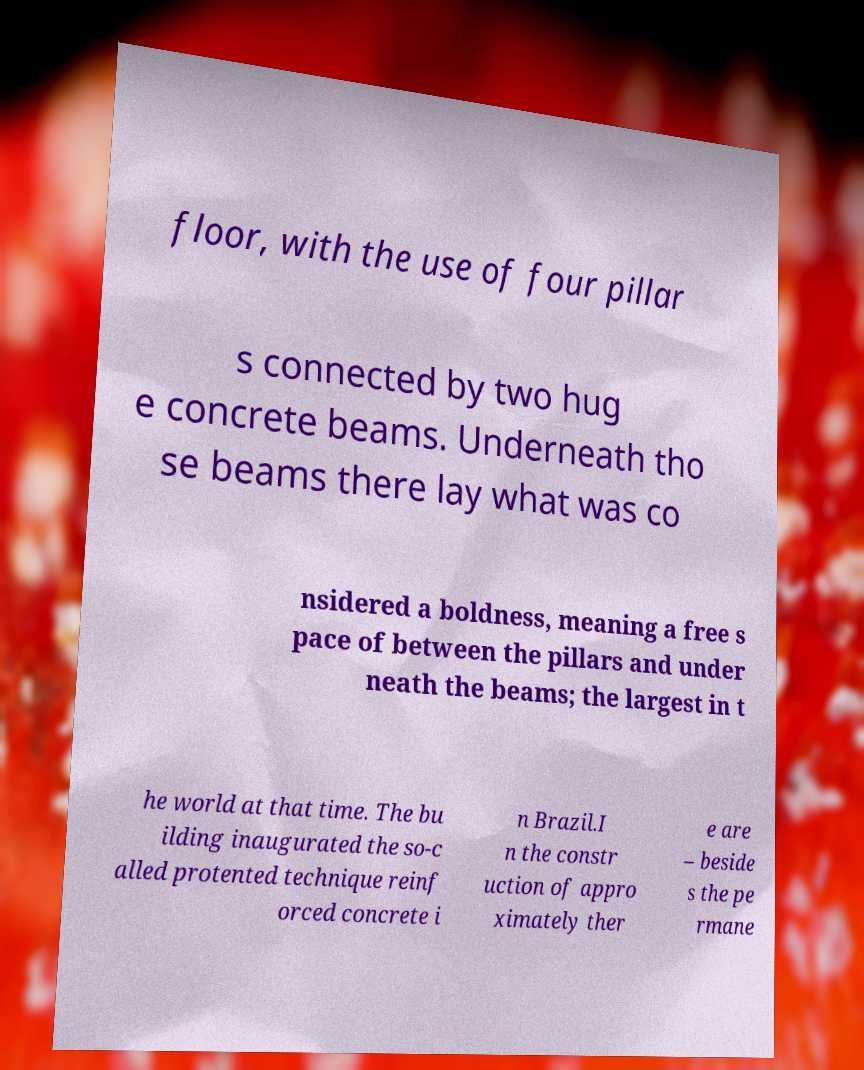Could you assist in decoding the text presented in this image and type it out clearly? floor, with the use of four pillar s connected by two hug e concrete beams. Underneath tho se beams there lay what was co nsidered a boldness, meaning a free s pace of between the pillars and under neath the beams; the largest in t he world at that time. The bu ilding inaugurated the so-c alled protented technique reinf orced concrete i n Brazil.I n the constr uction of appro ximately ther e are – beside s the pe rmane 